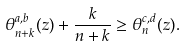Convert formula to latex. <formula><loc_0><loc_0><loc_500><loc_500>\theta _ { n + k } ^ { a , b } ( z ) + \frac { k } { n + k } \geq \theta _ { n } ^ { c , d } ( z ) .</formula> 